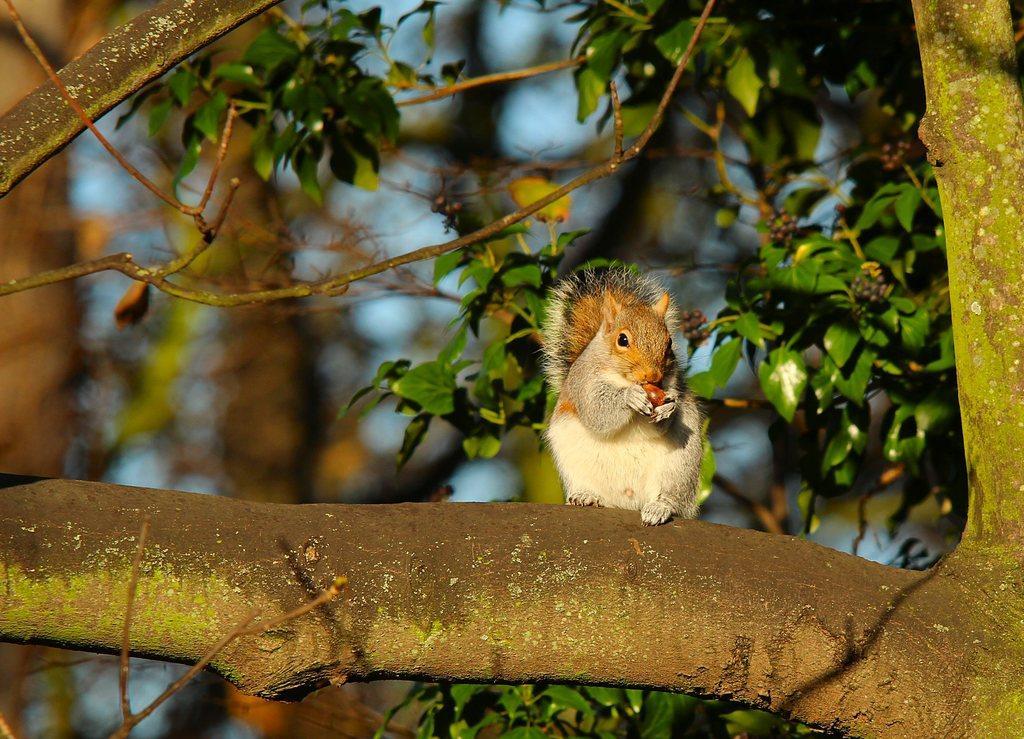Can you describe this image briefly? In this image we can see a squirrel sitting on the branch of a tree and holding a fruit in its hands. In the background we can see tree with fruits and sky. 